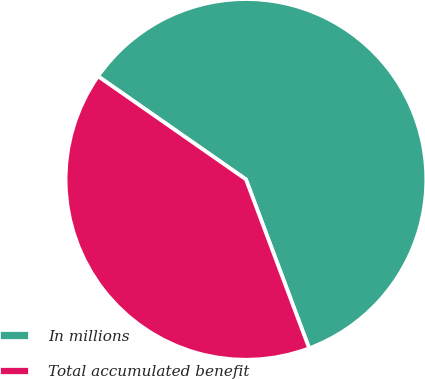Convert chart. <chart><loc_0><loc_0><loc_500><loc_500><pie_chart><fcel>In millions<fcel>Total accumulated benefit<nl><fcel>59.61%<fcel>40.39%<nl></chart> 